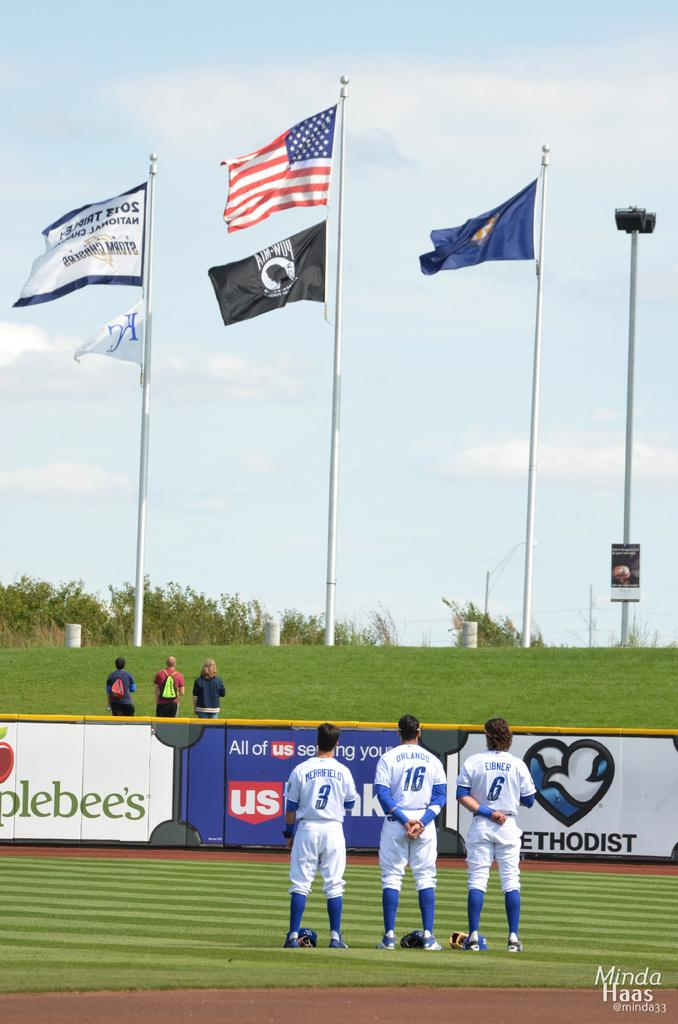<image>
Summarize the visual content of the image. Baseball players Merrifield, Orlando and Eibner stand facing the American flag. 